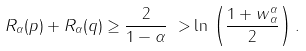<formula> <loc_0><loc_0><loc_500><loc_500>R _ { \alpha } ( p ) + R _ { \alpha } ( q ) \geq \frac { 2 } { 1 - \alpha } { \ > } \ln \, \left ( \frac { 1 + \| w \| _ { \alpha } ^ { \alpha } } { 2 } \right ) .</formula> 